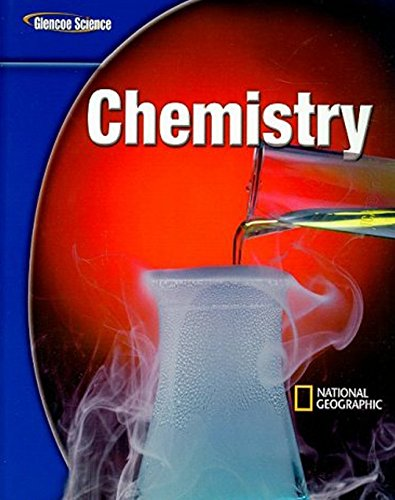Is this book related to Crafts, Hobbies & Home? No, this textbook is centered on educational content for chemistry and does not relate to crafts, hobbies or home-related topics. 